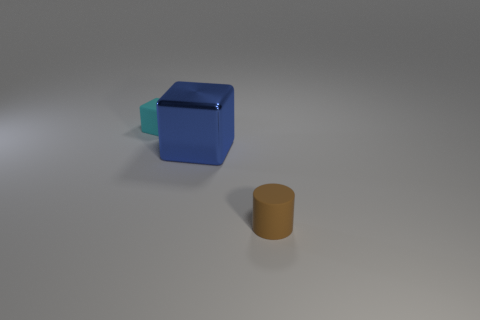What is the material of the cyan object that is the same shape as the big blue thing?
Ensure brevity in your answer.  Rubber. There is a brown object; is its shape the same as the small rubber thing that is to the left of the small brown thing?
Your answer should be very brief. No. The object that is both right of the small cyan matte thing and behind the brown cylinder is what color?
Provide a short and direct response. Blue. Are there any big metallic objects?
Offer a very short reply. Yes. Are there the same number of small brown rubber cylinders behind the rubber cylinder and large blue metal blocks?
Give a very brief answer. No. What number of other things are there of the same shape as the brown matte thing?
Offer a terse response. 0. What shape is the brown object?
Keep it short and to the point. Cylinder. Is the small cyan cube made of the same material as the big blue cube?
Offer a terse response. No. Is the number of rubber objects on the left side of the large cube the same as the number of tiny rubber cubes in front of the small brown rubber object?
Your answer should be very brief. No. There is a cube to the right of the tiny matte thing behind the small brown thing; are there any tiny brown cylinders on the left side of it?
Keep it short and to the point. No. 